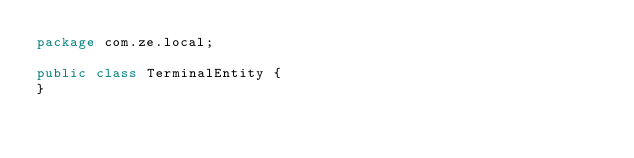Convert code to text. <code><loc_0><loc_0><loc_500><loc_500><_Java_>package com.ze.local;

public class TerminalEntity {
}
</code> 